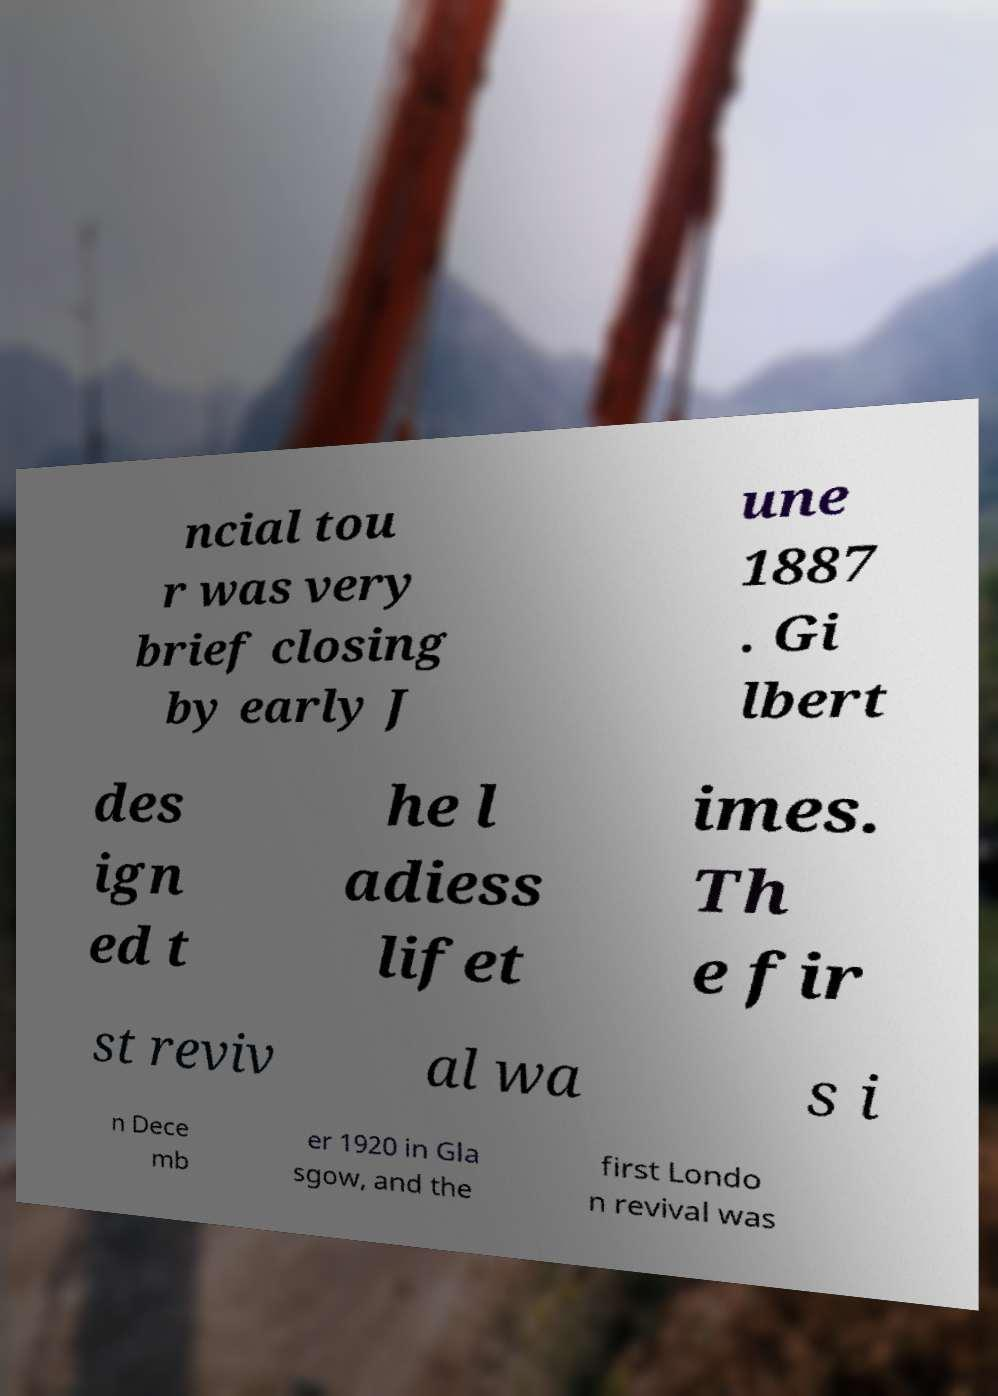Please read and relay the text visible in this image. What does it say? ncial tou r was very brief closing by early J une 1887 . Gi lbert des ign ed t he l adiess lifet imes. Th e fir st reviv al wa s i n Dece mb er 1920 in Gla sgow, and the first Londo n revival was 